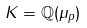Convert formula to latex. <formula><loc_0><loc_0><loc_500><loc_500>K = \mathbb { Q } ( \mu _ { p } )</formula> 